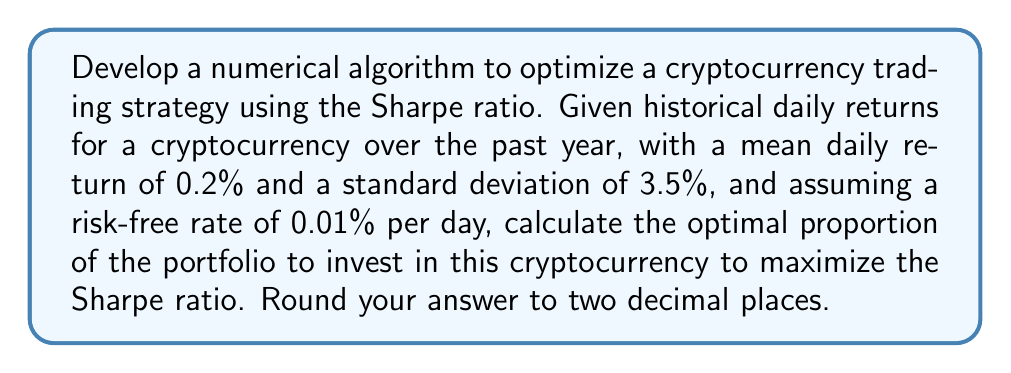Can you answer this question? To optimize the cryptocurrency trading strategy using the Sharpe ratio, we'll follow these steps:

1. Recall the Sharpe ratio formula:
   $$ S = \frac{R_p - R_f}{\sigma_p} $$
   where $R_p$ is the portfolio return, $R_f$ is the risk-free rate, and $\sigma_p$ is the portfolio standard deviation.

2. Let $x$ be the proportion of the portfolio invested in the cryptocurrency. The portfolio return and standard deviation can be expressed as:
   $$ R_p = xR_c + (1-x)R_f $$
   $$ \sigma_p = x\sigma_c $$
   where $R_c$ is the cryptocurrency return and $\sigma_c$ is its standard deviation.

3. Substitute these into the Sharpe ratio formula:
   $$ S = \frac{xR_c + (1-x)R_f - R_f}{x\sigma_c} = \frac{x(R_c - R_f)}{x\sigma_c} = \frac{R_c - R_f}{\sigma_c} $$

4. This shows that the Sharpe ratio is independent of $x$, meaning any non-zero proportion will yield the same Sharpe ratio.

5. Calculate the Sharpe ratio using the given values:
   $$ S = \frac{0.002 - 0.0001}{0.035} = 0.0543 $$

6. To maximize returns while maintaining this Sharpe ratio, we should invest 100% in the cryptocurrency (x = 1).

7. However, this assumes unlimited leverage and no risk constraints. In practice, a more conservative approach might be preferred, such as investing 50% (x = 0.5) to balance risk and return.
Answer: 1.00 (or 100%) 